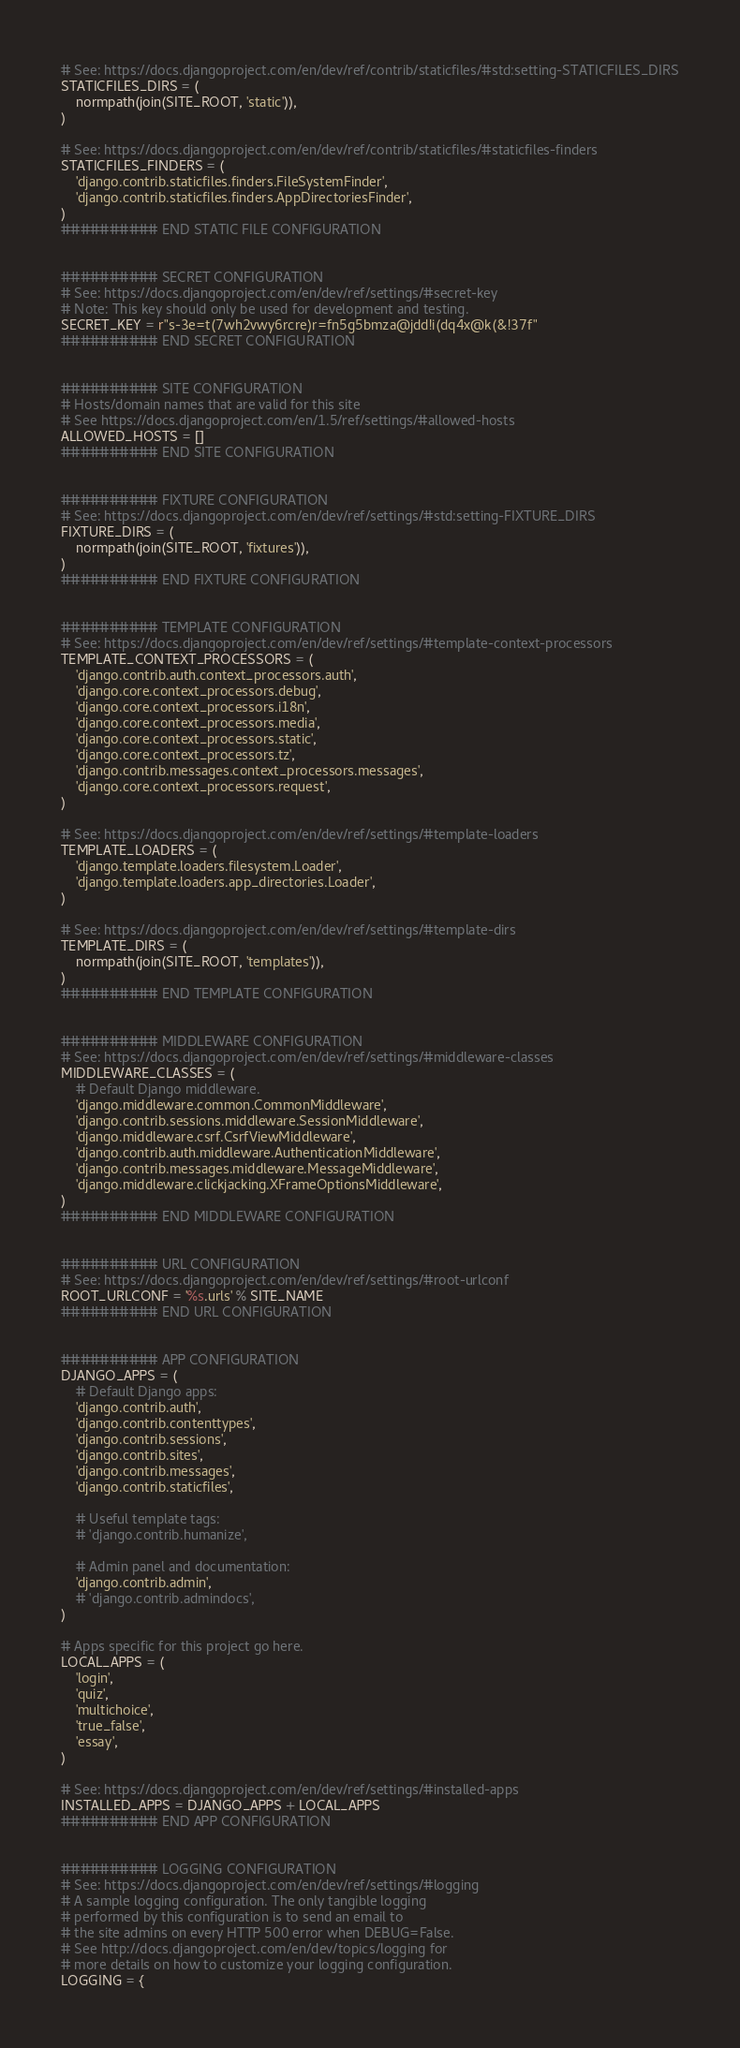Convert code to text. <code><loc_0><loc_0><loc_500><loc_500><_Python_>
# See: https://docs.djangoproject.com/en/dev/ref/contrib/staticfiles/#std:setting-STATICFILES_DIRS
STATICFILES_DIRS = (
    normpath(join(SITE_ROOT, 'static')),
)

# See: https://docs.djangoproject.com/en/dev/ref/contrib/staticfiles/#staticfiles-finders
STATICFILES_FINDERS = (
    'django.contrib.staticfiles.finders.FileSystemFinder',
    'django.contrib.staticfiles.finders.AppDirectoriesFinder',
)
########## END STATIC FILE CONFIGURATION


########## SECRET CONFIGURATION
# See: https://docs.djangoproject.com/en/dev/ref/settings/#secret-key
# Note: This key should only be used for development and testing.
SECRET_KEY = r"s-3e=t(7wh2vwy6rcre)r=fn5g5bmza@jdd!i(dq4x@k(&!37f"
########## END SECRET CONFIGURATION


########## SITE CONFIGURATION
# Hosts/domain names that are valid for this site
# See https://docs.djangoproject.com/en/1.5/ref/settings/#allowed-hosts
ALLOWED_HOSTS = []
########## END SITE CONFIGURATION


########## FIXTURE CONFIGURATION
# See: https://docs.djangoproject.com/en/dev/ref/settings/#std:setting-FIXTURE_DIRS
FIXTURE_DIRS = (
    normpath(join(SITE_ROOT, 'fixtures')),
)
########## END FIXTURE CONFIGURATION


########## TEMPLATE CONFIGURATION
# See: https://docs.djangoproject.com/en/dev/ref/settings/#template-context-processors
TEMPLATE_CONTEXT_PROCESSORS = (
    'django.contrib.auth.context_processors.auth',
    'django.core.context_processors.debug',
    'django.core.context_processors.i18n',
    'django.core.context_processors.media',
    'django.core.context_processors.static',
    'django.core.context_processors.tz',
    'django.contrib.messages.context_processors.messages',
    'django.core.context_processors.request',
)

# See: https://docs.djangoproject.com/en/dev/ref/settings/#template-loaders
TEMPLATE_LOADERS = (
    'django.template.loaders.filesystem.Loader',
    'django.template.loaders.app_directories.Loader',
)

# See: https://docs.djangoproject.com/en/dev/ref/settings/#template-dirs
TEMPLATE_DIRS = (
    normpath(join(SITE_ROOT, 'templates')),
)
########## END TEMPLATE CONFIGURATION


########## MIDDLEWARE CONFIGURATION
# See: https://docs.djangoproject.com/en/dev/ref/settings/#middleware-classes
MIDDLEWARE_CLASSES = (
    # Default Django middleware.
    'django.middleware.common.CommonMiddleware',
    'django.contrib.sessions.middleware.SessionMiddleware',
    'django.middleware.csrf.CsrfViewMiddleware',
    'django.contrib.auth.middleware.AuthenticationMiddleware',
    'django.contrib.messages.middleware.MessageMiddleware',
    'django.middleware.clickjacking.XFrameOptionsMiddleware',
)
########## END MIDDLEWARE CONFIGURATION


########## URL CONFIGURATION
# See: https://docs.djangoproject.com/en/dev/ref/settings/#root-urlconf
ROOT_URLCONF = '%s.urls' % SITE_NAME
########## END URL CONFIGURATION


########## APP CONFIGURATION
DJANGO_APPS = (
    # Default Django apps:
    'django.contrib.auth',
    'django.contrib.contenttypes',
    'django.contrib.sessions',
    'django.contrib.sites',
    'django.contrib.messages',
    'django.contrib.staticfiles',

    # Useful template tags:
    # 'django.contrib.humanize',

    # Admin panel and documentation:
    'django.contrib.admin',
    # 'django.contrib.admindocs',
)

# Apps specific for this project go here.
LOCAL_APPS = (
    'login',
    'quiz',
    'multichoice',
    'true_false',
    'essay',
)

# See: https://docs.djangoproject.com/en/dev/ref/settings/#installed-apps
INSTALLED_APPS = DJANGO_APPS + LOCAL_APPS
########## END APP CONFIGURATION


########## LOGGING CONFIGURATION
# See: https://docs.djangoproject.com/en/dev/ref/settings/#logging
# A sample logging configuration. The only tangible logging
# performed by this configuration is to send an email to
# the site admins on every HTTP 500 error when DEBUG=False.
# See http://docs.djangoproject.com/en/dev/topics/logging for
# more details on how to customize your logging configuration.
LOGGING = {</code> 